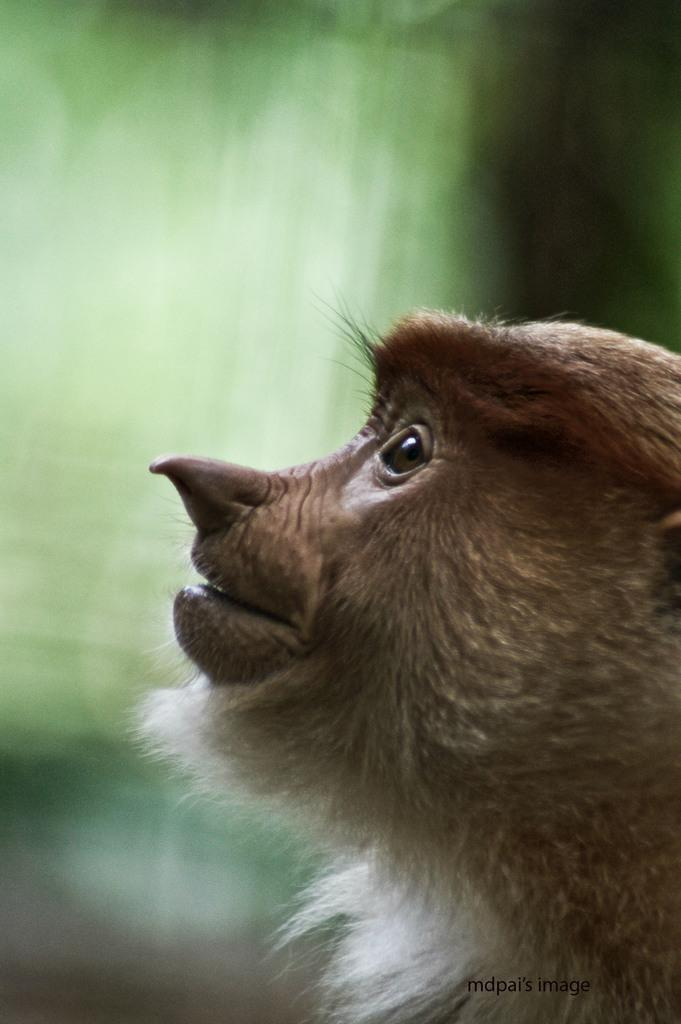What type of animal is present in the image? There is a monkey in the image. Can you describe the background of the image? The background of the image is blurred. What type of caption is present below the image? There is no caption present below the image; it only contains the monkey and the blurred background. What type of harmony is being depicted in the image? The image does not depict any specific harmony; it simply features a monkey and a blurred background. 